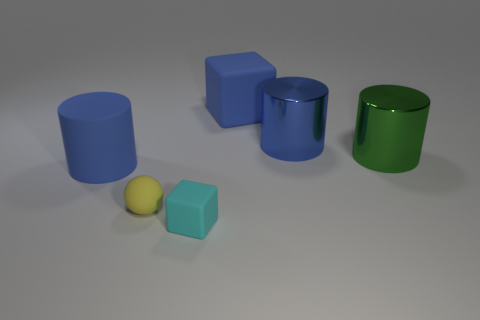Subtract all blue metallic cylinders. How many cylinders are left? 2 Add 2 brown cylinders. How many objects exist? 8 Subtract all green cylinders. How many cylinders are left? 2 Subtract 1 blue blocks. How many objects are left? 5 Subtract all cubes. How many objects are left? 4 Subtract 1 balls. How many balls are left? 0 Subtract all brown cylinders. Subtract all gray cubes. How many cylinders are left? 3 Subtract all red spheres. How many green cylinders are left? 1 Subtract all red matte things. Subtract all yellow matte spheres. How many objects are left? 5 Add 5 small spheres. How many small spheres are left? 6 